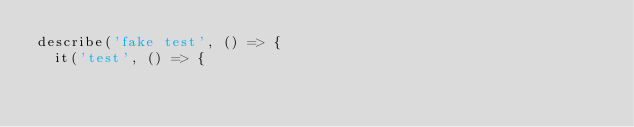<code> <loc_0><loc_0><loc_500><loc_500><_TypeScript_>describe('fake test', () => {
  it('test', () => {</code> 